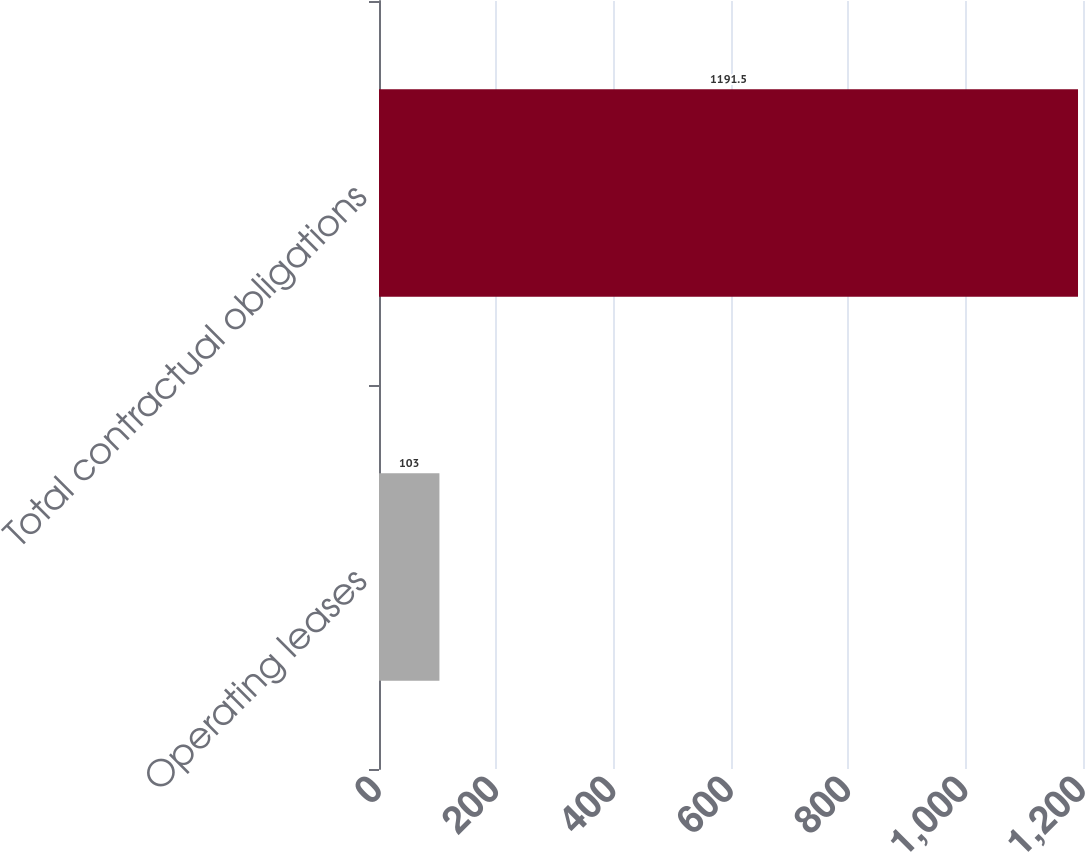<chart> <loc_0><loc_0><loc_500><loc_500><bar_chart><fcel>Operating leases<fcel>Total contractual obligations<nl><fcel>103<fcel>1191.5<nl></chart> 